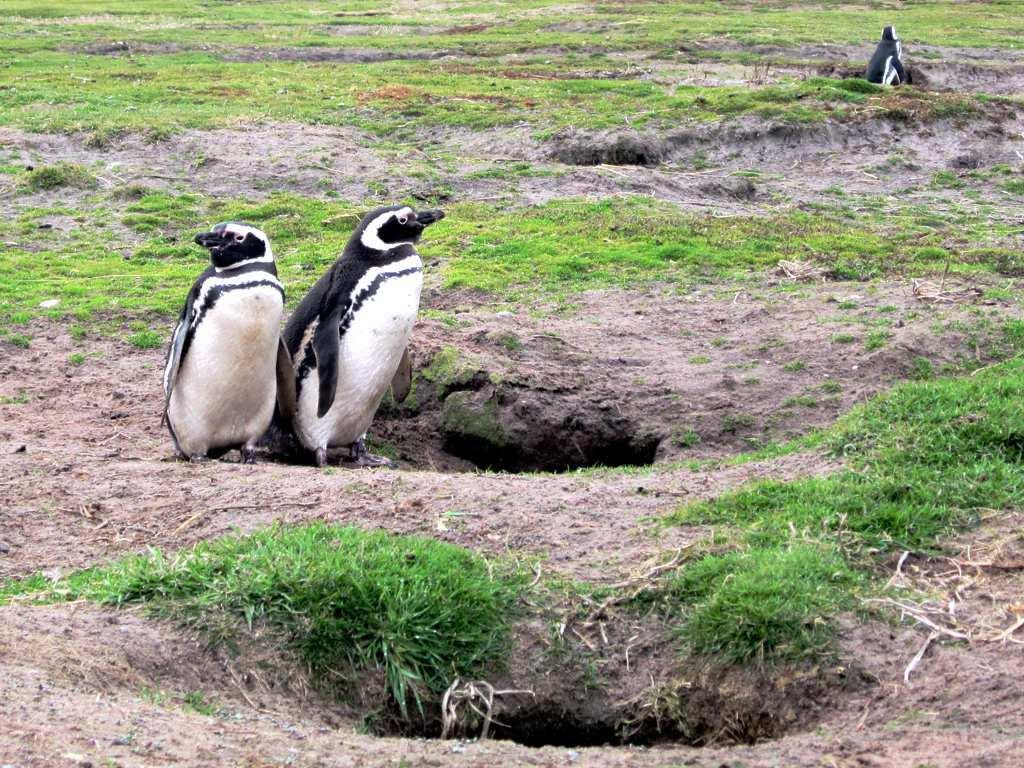What animals are in the center of the image? There are two penguins in the center of the image. What type of vegetation is at the bottom of the image? There is grass at the bottom of the image. Where is the third penguin located in the image? There is another penguin at the right side of the image. What type of texture can be seen on the soap in the image? There is no soap present in the image, so it is not possible to determine its texture. 